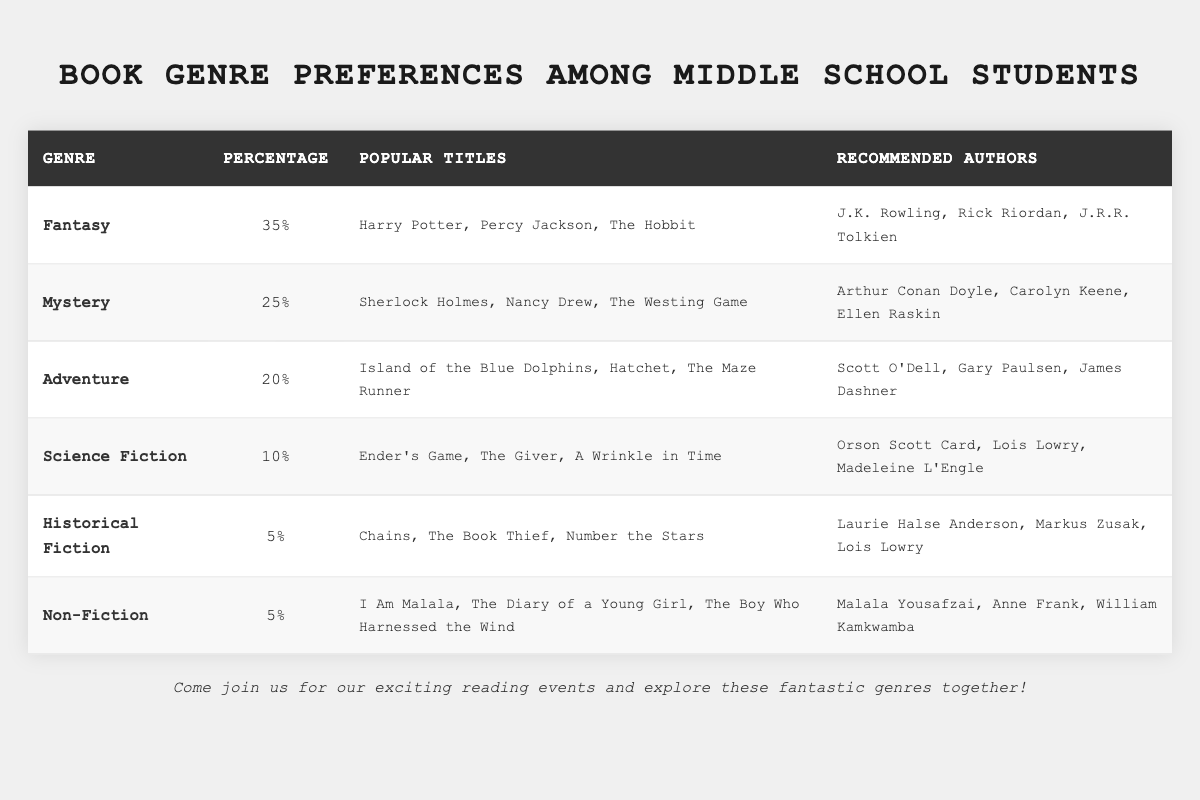What is the most popular book genre among middle school students? The table shows that Fantasy has a percentage of 35, which is higher than any other genre listed.
Answer: Fantasy Which genre has the least preference among students? Historical Fiction and Non-Fiction both have a percentage of 5, making them the least preferred genres.
Answer: Historical Fiction and Non-Fiction How many students prefer Adventure books if the table shows 20%? To find the number of students, we would need the total number of students surveyed. However, the percentage indicates that 20% of the surveyed students prefer Adventure.
Answer: Not determinable without total student number What is the combined percentage of students who prefer Science Fiction and Historical Fiction? The percentage of Science Fiction is 10, and Historical Fiction is 5. Adding these gives 10 + 5 = 15.
Answer: 15 Do more students prefer Mystery or Adventure books? Mystery has a percentage of 25, while Adventure has 20. Comparing these values, Mystery is preferred more.
Answer: Mystery What percentage of students prefer genres other than Fantasy? The total percentage of all genres is 100, and Fantasy is 35. Thus, 100 - 35 = 65% of students prefer other genres.
Answer: 65 How many genres have a preference percentage of 10 or less? Looking at the table, Science Fiction, Historical Fiction, and Non-Fiction (10% and 5% each) total to three genres.
Answer: 3 If a student enjoys reading "The Giver," which author should they look for? "The Giver" is a popular title in the Science Fiction genre, and the recommended author is Lois Lowry.
Answer: Lois Lowry Which two authors are recommended for the Adventure genre? The Adventure genre recommends Scott O'Dell and Gary Paulsen, according to the table.
Answer: Scott O'Dell and Gary Paulsen What is the average percentage preference of the genres listed in the table? Calculate the average by adding the percentages (35 + 25 + 20 + 10 + 5 + 5 = 100) and dividing by the number of genres (6). The average is 100 / 6 = approximately 16.67.
Answer: 16.67 